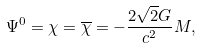Convert formula to latex. <formula><loc_0><loc_0><loc_500><loc_500>\Psi ^ { 0 } = \chi = \overline { \chi } = - \frac { 2 \sqrt { 2 } G } { c ^ { 2 } } M ,</formula> 